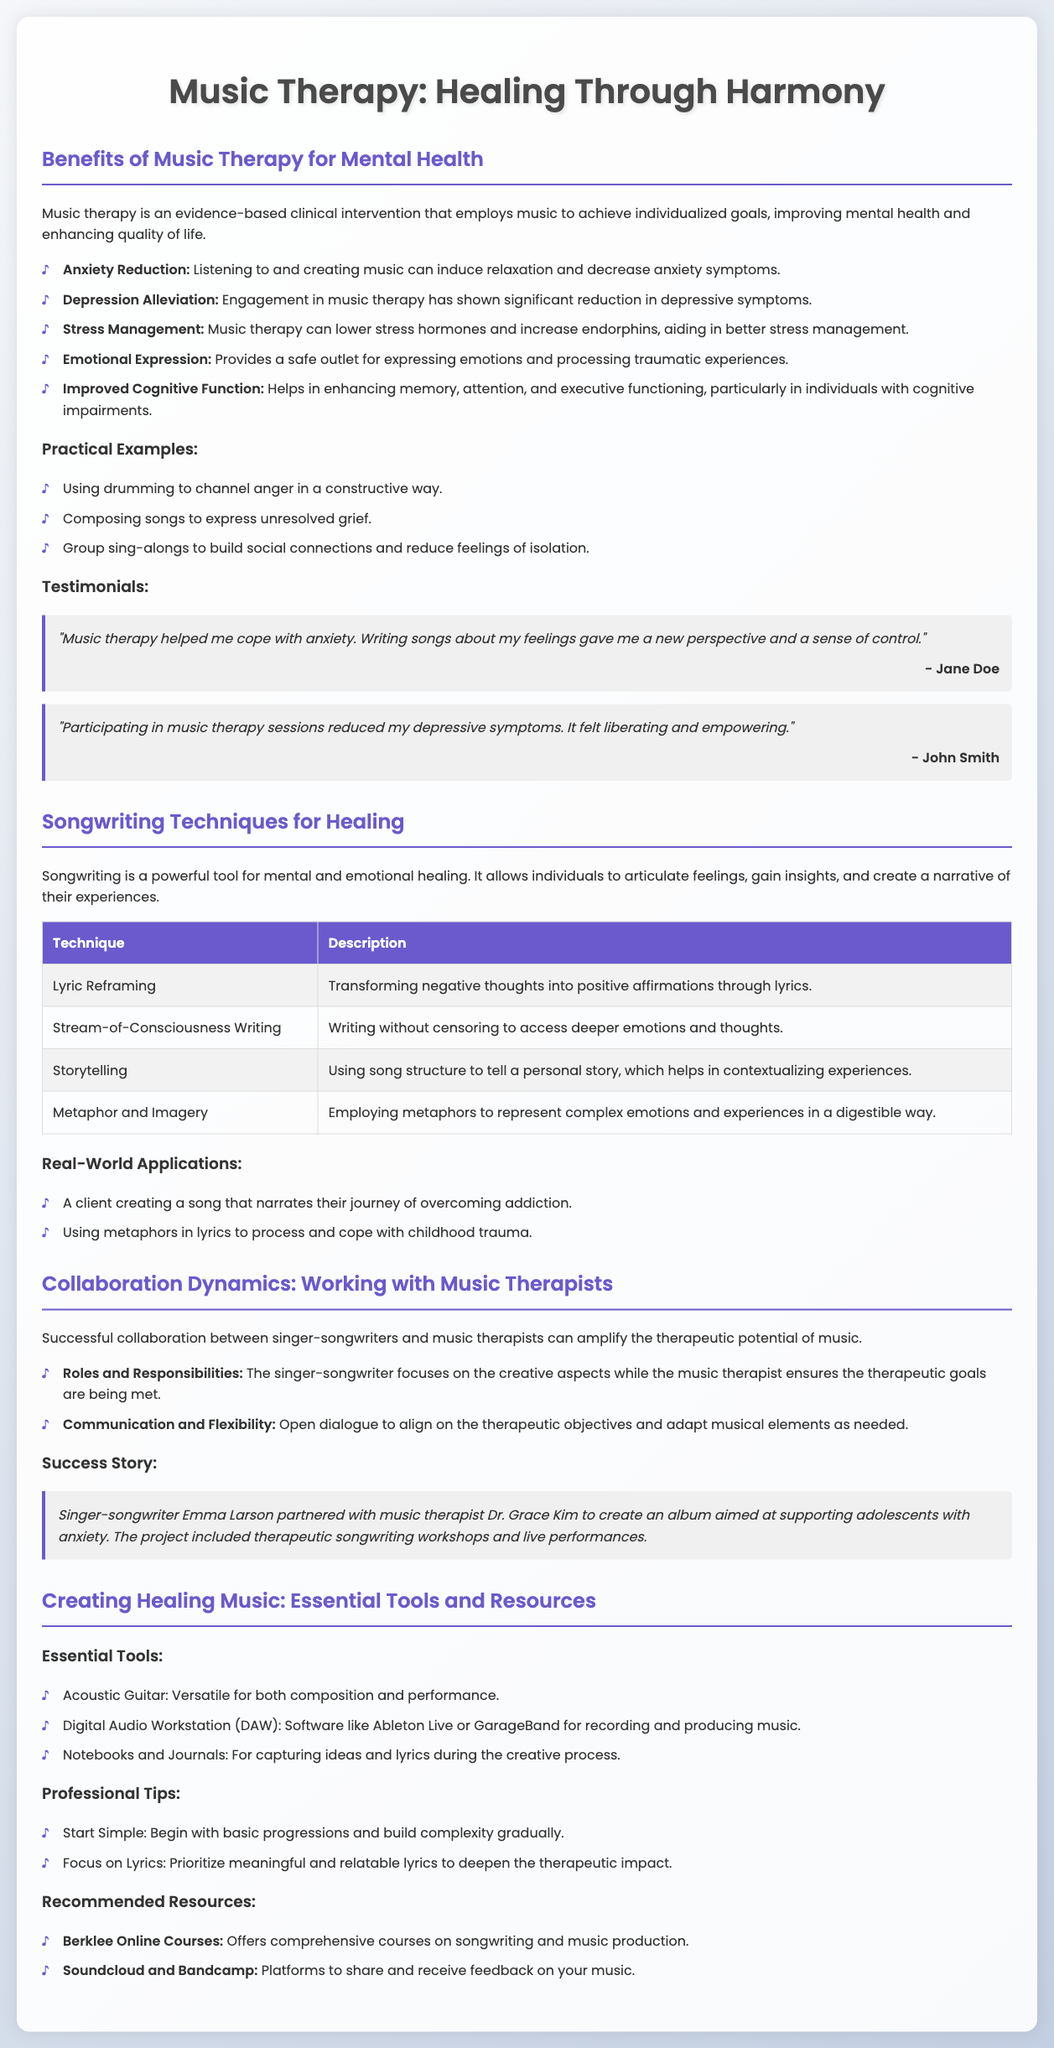What are the benefits of music therapy for mental health? The benefits of music therapy for mental health mentioned in the document include anxiety reduction, depression alleviation, stress management, emotional expression, and improved cognitive function.
Answer: Anxiety reduction, depression alleviation, stress management, emotional expression, improved cognitive function What technique involves writing without censoring? The technique of writing without censoring to access deeper emotions and thoughts is called Stream-of-Consciousness Writing.
Answer: Stream-of-Consciousness Writing What role does a music therapist play in collaboration with a singer-songwriter? The music therapist ensures the therapeutic goals are being met while the singer-songwriter focuses on the creative aspects.
Answer: Ensures therapeutic goals are met What essential tool is recommended for capturing ideas and lyrics? Notebooks and Journals are recommended for capturing ideas and lyrics during the creative process.
Answer: Notebooks and Journals How does music therapy help with stress management? Music therapy lowers stress hormones and increases endorphins, aiding in better stress management.
Answer: Lowers stress hormones and increases endorphins Which singer-songwriter is mentioned in a success story? The success story highlights singer-songwriter Emma Larson who collaborated with music therapist Dr. Grace Kim.
Answer: Emma Larson What is one practical example of music therapy mentioned? One practical example of music therapy is using drumming to channel anger in a constructive way.
Answer: Using drumming to channel anger What does lyric reframing involve? Lyric reframing involves transforming negative thoughts into positive affirmations through lyrics.
Answer: Transforming negative thoughts into positive affirmations What are the platforms recommended for sharing music? Soundcloud and Bandcamp are recommended platforms for sharing and receiving feedback on music.
Answer: Soundcloud and Bandcamp 